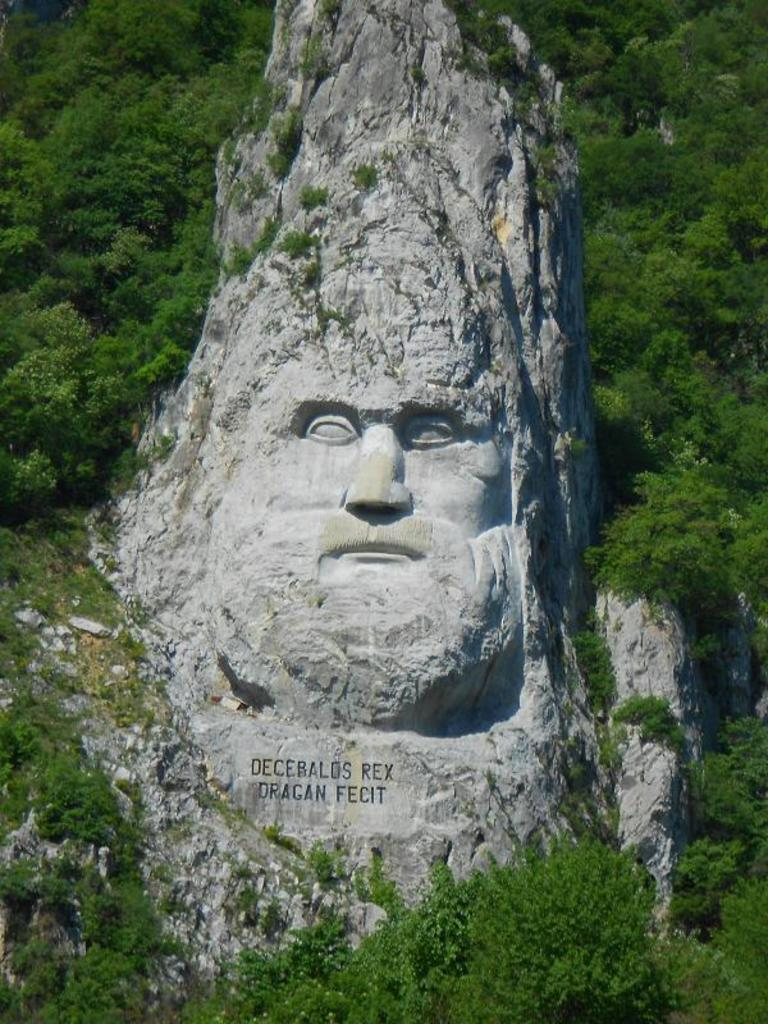What is the main subject of the image? There is a person sculpture in the image. What else can be seen in the image besides the sculpture? There is text on a hill and many trees visible in the image. How many deer can be seen in the image? There are no deer present in the image. What type of emotion is expressed by the text on the hill? The text on the hill cannot express emotions, as it is an inanimate object. 